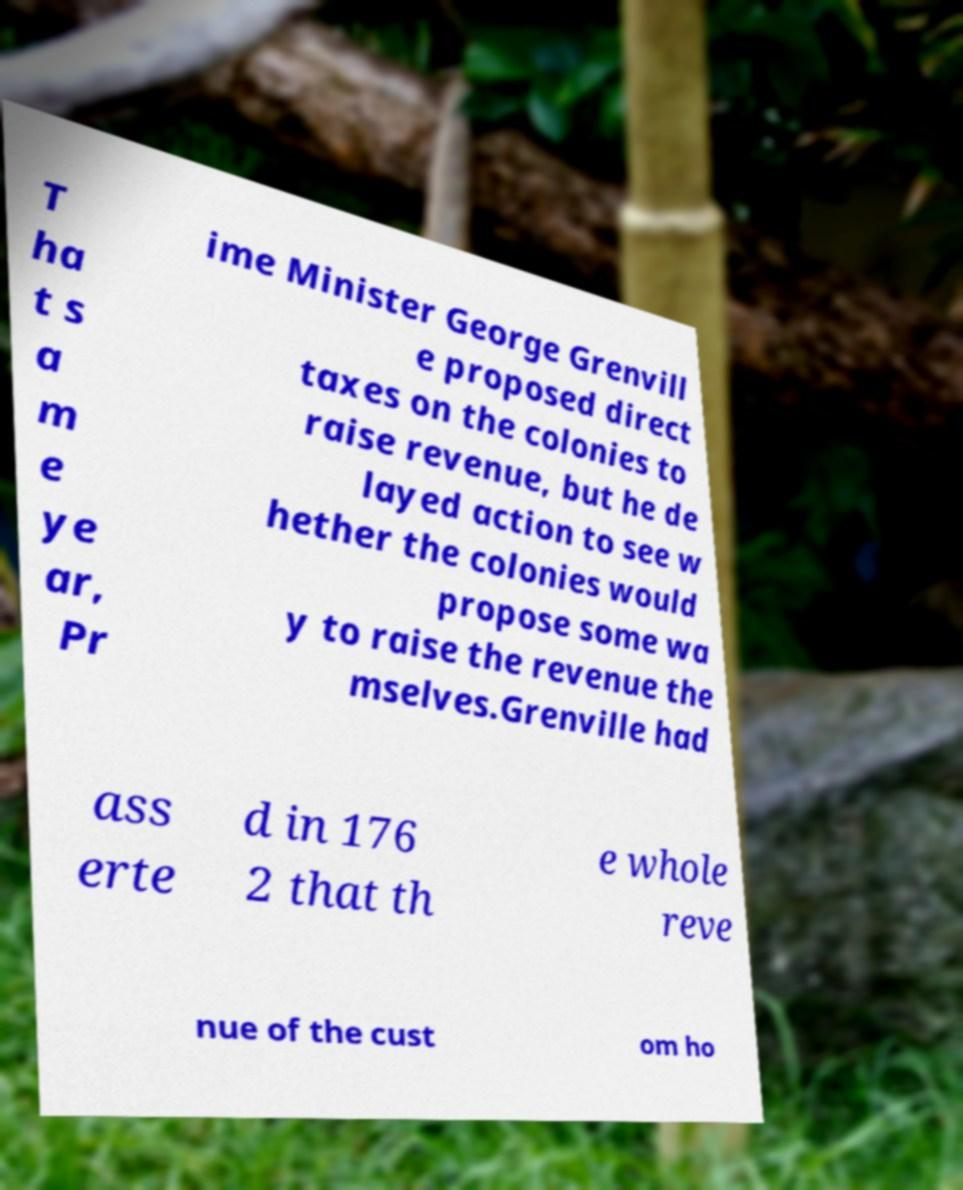Could you extract and type out the text from this image? T ha t s a m e ye ar, Pr ime Minister George Grenvill e proposed direct taxes on the colonies to raise revenue, but he de layed action to see w hether the colonies would propose some wa y to raise the revenue the mselves.Grenville had ass erte d in 176 2 that th e whole reve nue of the cust om ho 